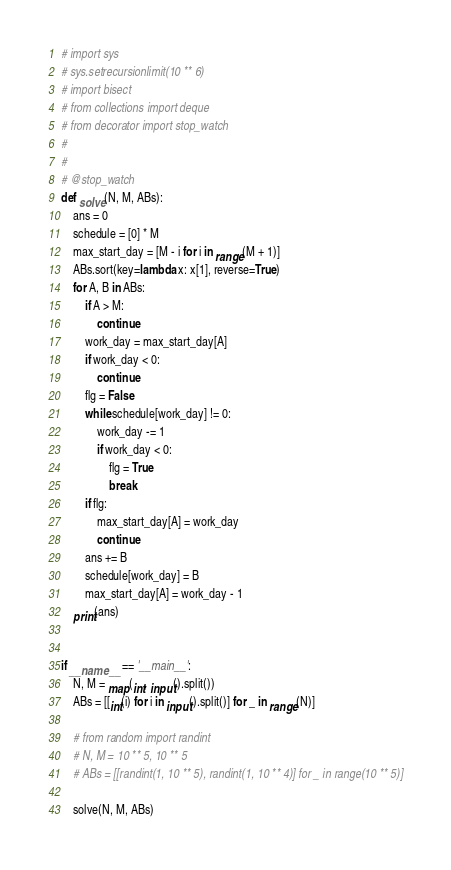<code> <loc_0><loc_0><loc_500><loc_500><_Python_># import sys
# sys.setrecursionlimit(10 ** 6)
# import bisect
# from collections import deque
# from decorator import stop_watch
# 
# 
# @stop_watch
def solve(N, M, ABs):
    ans = 0
    schedule = [0] * M
    max_start_day = [M - i for i in range(M + 1)]
    ABs.sort(key=lambda x: x[1], reverse=True)
    for A, B in ABs:
        if A > M:
            continue
        work_day = max_start_day[A]
        if work_day < 0:
            continue
        flg = False
        while schedule[work_day] != 0:
            work_day -= 1
            if work_day < 0:
                flg = True
                break
        if flg:
            max_start_day[A] = work_day
            continue
        ans += B
        schedule[work_day] = B
        max_start_day[A] = work_day - 1
    print(ans)


if __name__ == '__main__':
    N, M = map(int, input().split())
    ABs = [[int(i) for i in input().split()] for _ in range(N)]

    # from random import randint
    # N, M = 10 ** 5, 10 ** 5
    # ABs = [[randint(1, 10 ** 5), randint(1, 10 ** 4)] for _ in range(10 ** 5)]

    solve(N, M, ABs)</code> 